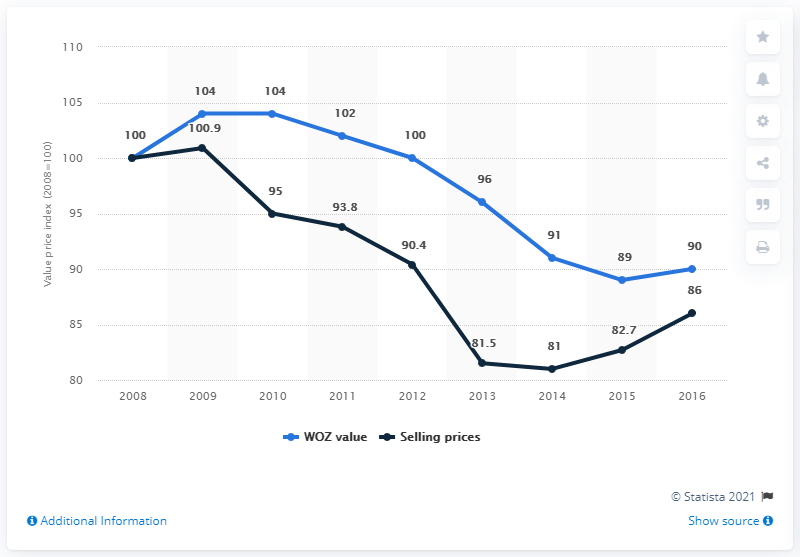List a handful of essential elements in this visual. The WOZ value index remains constant at 104 for two consecutive years. The WOZ value price index in 2013 was 96. Since 2015, the WOZ value has risen. 